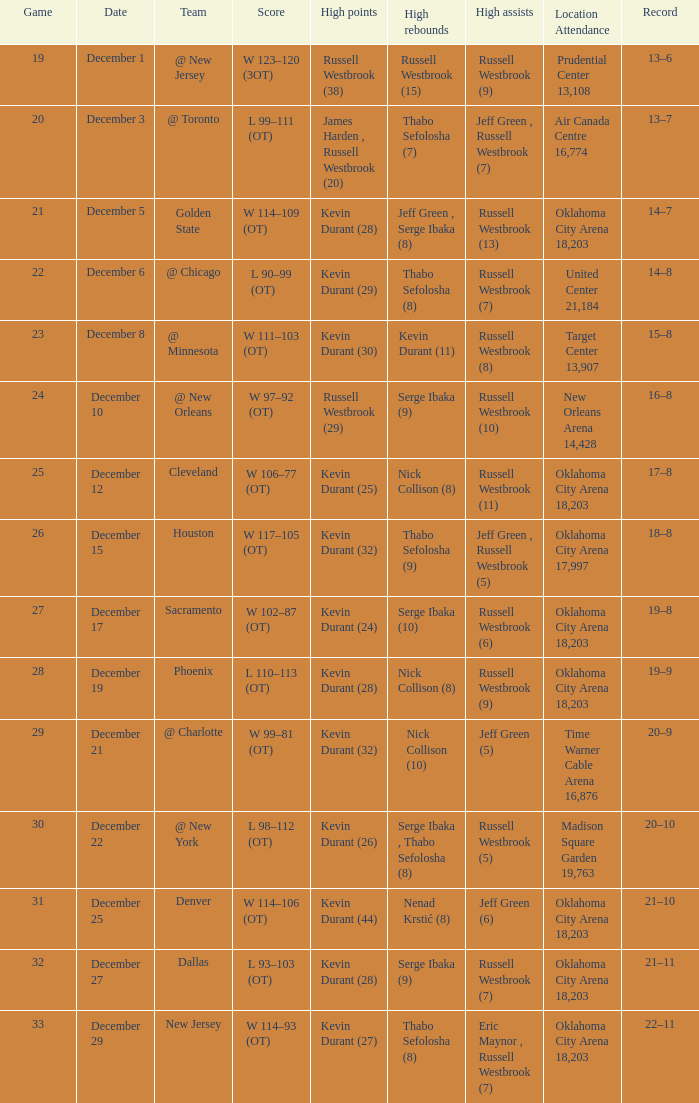What was the record on December 27? 21–11. 